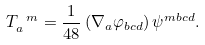<formula> <loc_0><loc_0><loc_500><loc_500>T _ { a } ^ { \ m } = \frac { 1 } { 4 8 } \left ( \nabla _ { a } \varphi _ { b c d } \right ) \psi ^ { m b c d } .</formula> 